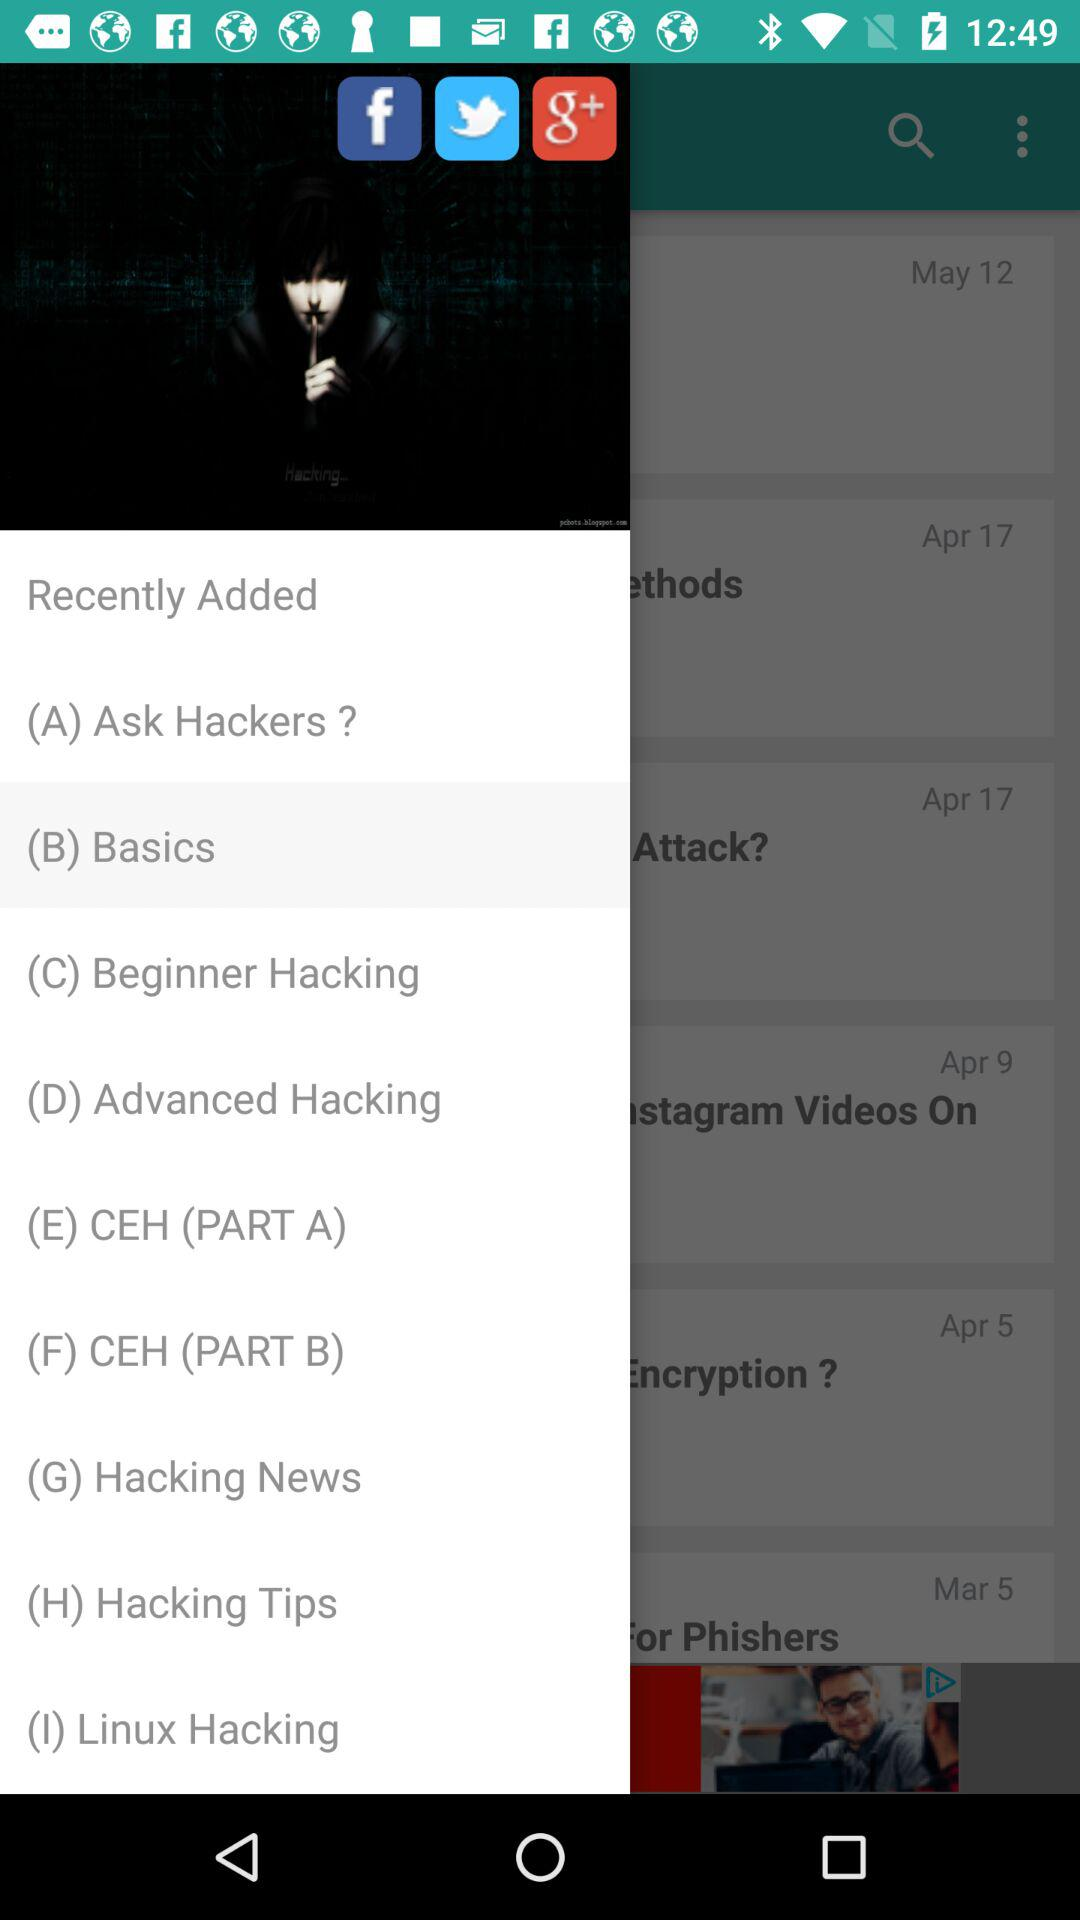Which applications can be used for sharing? The applications that can be used for sharing are "Facebook", "Twitter" and "Google Plus". 